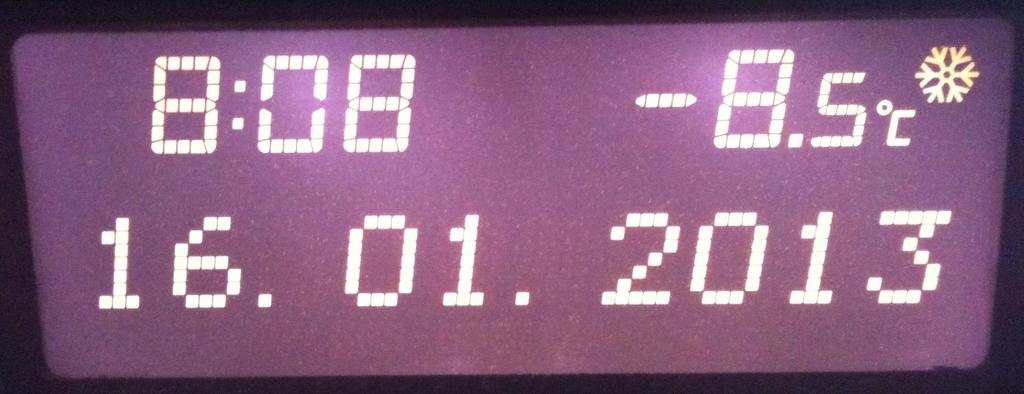What is the temperature shown on the screen?
Give a very brief answer. -8.5. What date is shown?
Your answer should be very brief. 16.01.2013. 